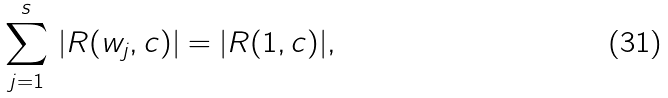<formula> <loc_0><loc_0><loc_500><loc_500>\sum _ { j = 1 } ^ { s } \, | R ( w _ { j } , c ) | = | R ( 1 , c ) | ,</formula> 